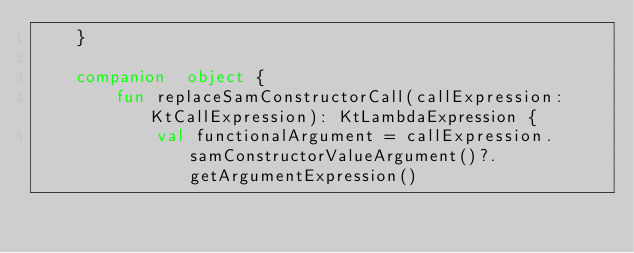<code> <loc_0><loc_0><loc_500><loc_500><_Kotlin_>    }

    companion  object {
        fun replaceSamConstructorCall(callExpression: KtCallExpression): KtLambdaExpression {
            val functionalArgument = callExpression.samConstructorValueArgument()?.getArgumentExpression()</code> 